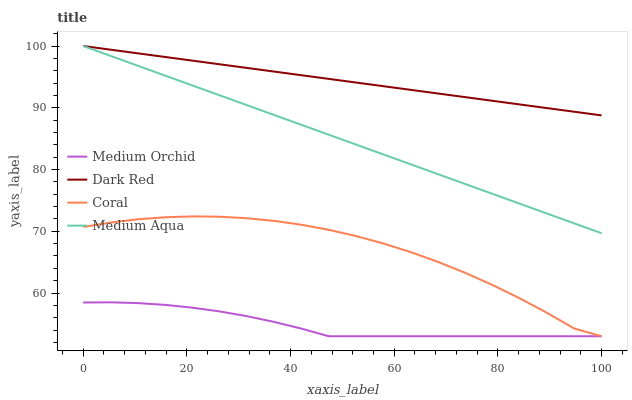Does Medium Orchid have the minimum area under the curve?
Answer yes or no. Yes. Does Dark Red have the maximum area under the curve?
Answer yes or no. Yes. Does Coral have the minimum area under the curve?
Answer yes or no. No. Does Coral have the maximum area under the curve?
Answer yes or no. No. Is Medium Aqua the smoothest?
Answer yes or no. Yes. Is Coral the roughest?
Answer yes or no. Yes. Is Medium Orchid the smoothest?
Answer yes or no. No. Is Medium Orchid the roughest?
Answer yes or no. No. Does Coral have the lowest value?
Answer yes or no. Yes. Does Medium Aqua have the lowest value?
Answer yes or no. No. Does Medium Aqua have the highest value?
Answer yes or no. Yes. Does Coral have the highest value?
Answer yes or no. No. Is Medium Orchid less than Dark Red?
Answer yes or no. Yes. Is Medium Aqua greater than Medium Orchid?
Answer yes or no. Yes. Does Coral intersect Medium Orchid?
Answer yes or no. Yes. Is Coral less than Medium Orchid?
Answer yes or no. No. Is Coral greater than Medium Orchid?
Answer yes or no. No. Does Medium Orchid intersect Dark Red?
Answer yes or no. No. 